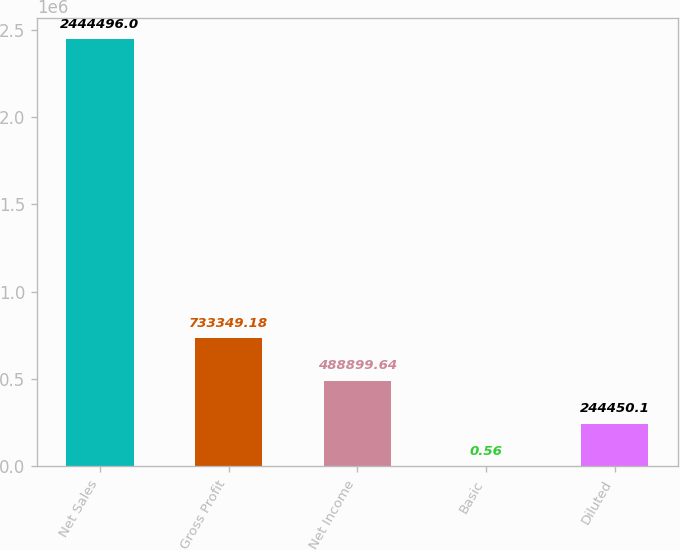<chart> <loc_0><loc_0><loc_500><loc_500><bar_chart><fcel>Net Sales<fcel>Gross Profit<fcel>Net Income<fcel>Basic<fcel>Diluted<nl><fcel>2.4445e+06<fcel>733349<fcel>488900<fcel>0.56<fcel>244450<nl></chart> 